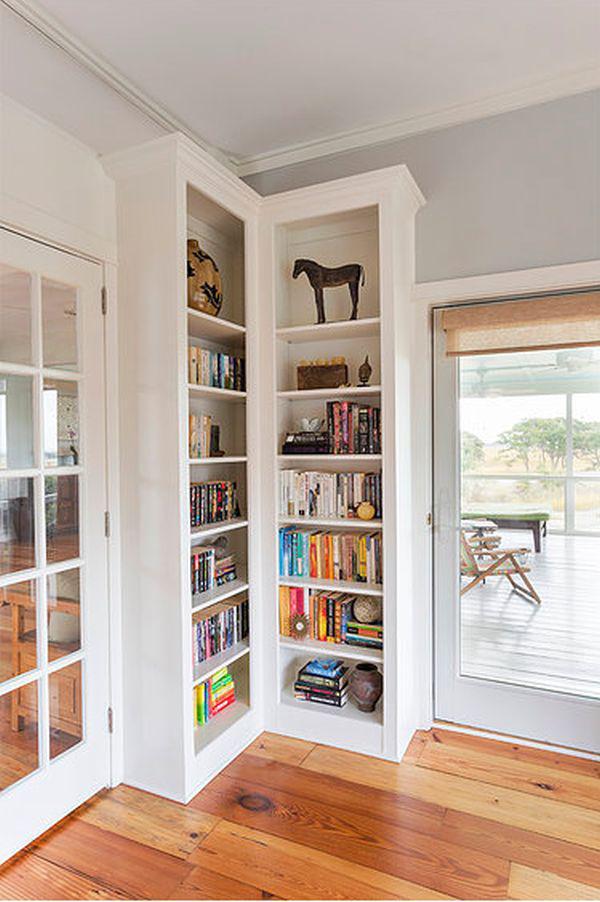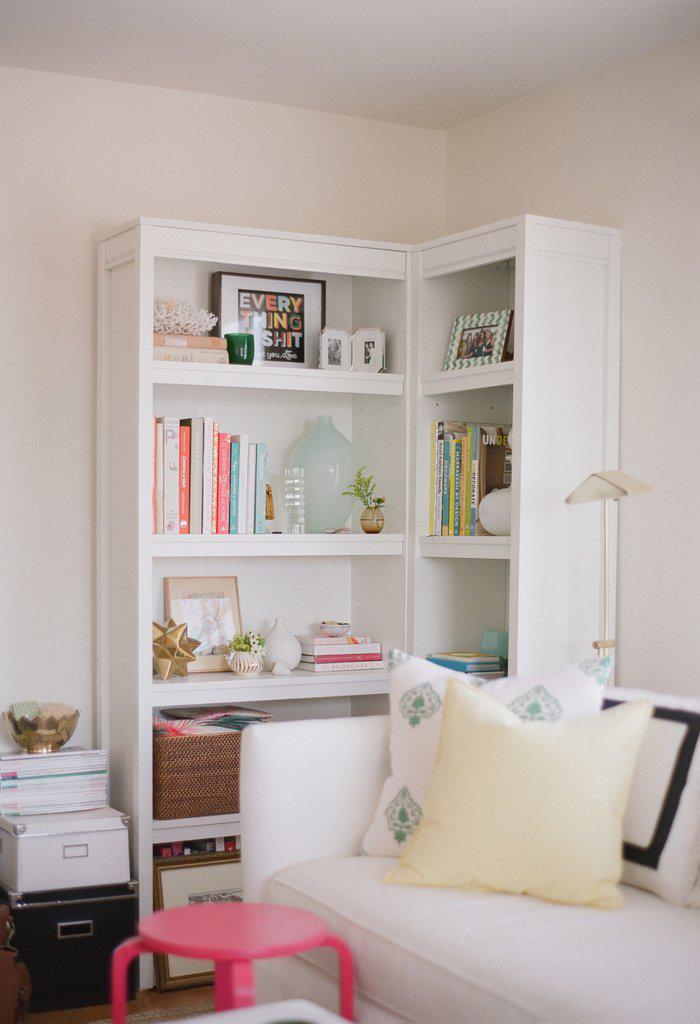The first image is the image on the left, the second image is the image on the right. Assess this claim about the two images: "An image features a black upright corner shelf unit with items displayed on some of the shelves.". Correct or not? Answer yes or no. No. The first image is the image on the left, the second image is the image on the right. Given the left and right images, does the statement "In one image the shelves are black." hold true? Answer yes or no. No. 